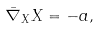Convert formula to latex. <formula><loc_0><loc_0><loc_500><loc_500>\bar { \nabla } _ { X } X = - a ,</formula> 